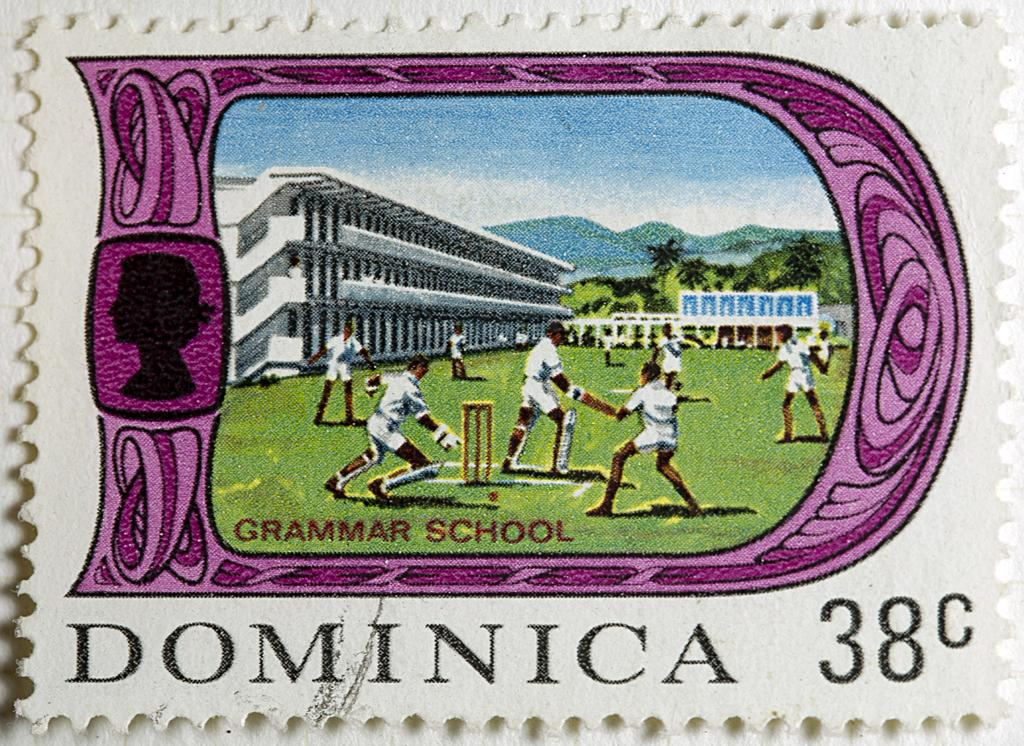<image>
Write a terse but informative summary of the picture. a little postcard that has Dominica 38 on it 